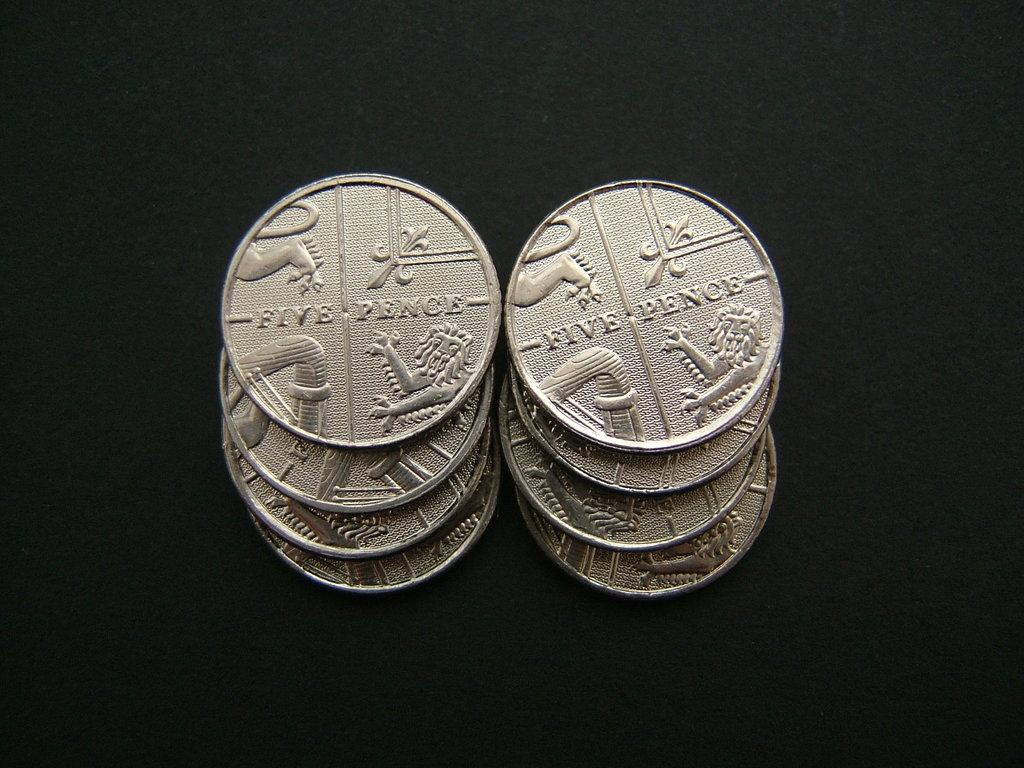<image>
Present a compact description of the photo's key features. two stacks of four silver coins that say 'five pence' on them 